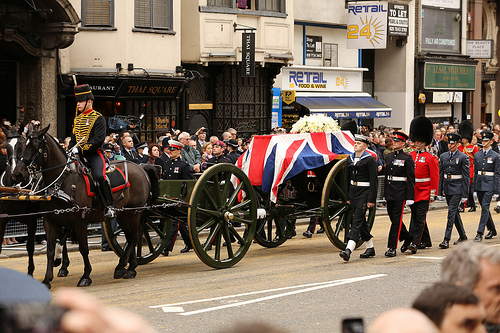What is the vehicle that the horse is pulling called? The vehicle being pulled by the horse is called a wagon. 